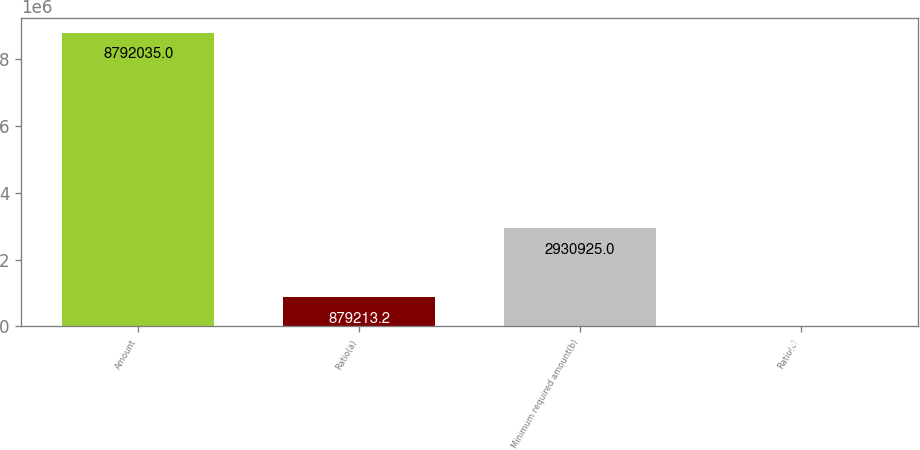Convert chart. <chart><loc_0><loc_0><loc_500><loc_500><bar_chart><fcel>Amount<fcel>Ratio(a)<fcel>Minimum required amount(b)<fcel>Ratio(c)<nl><fcel>8.79204e+06<fcel>879213<fcel>2.93092e+06<fcel>10.78<nl></chart> 